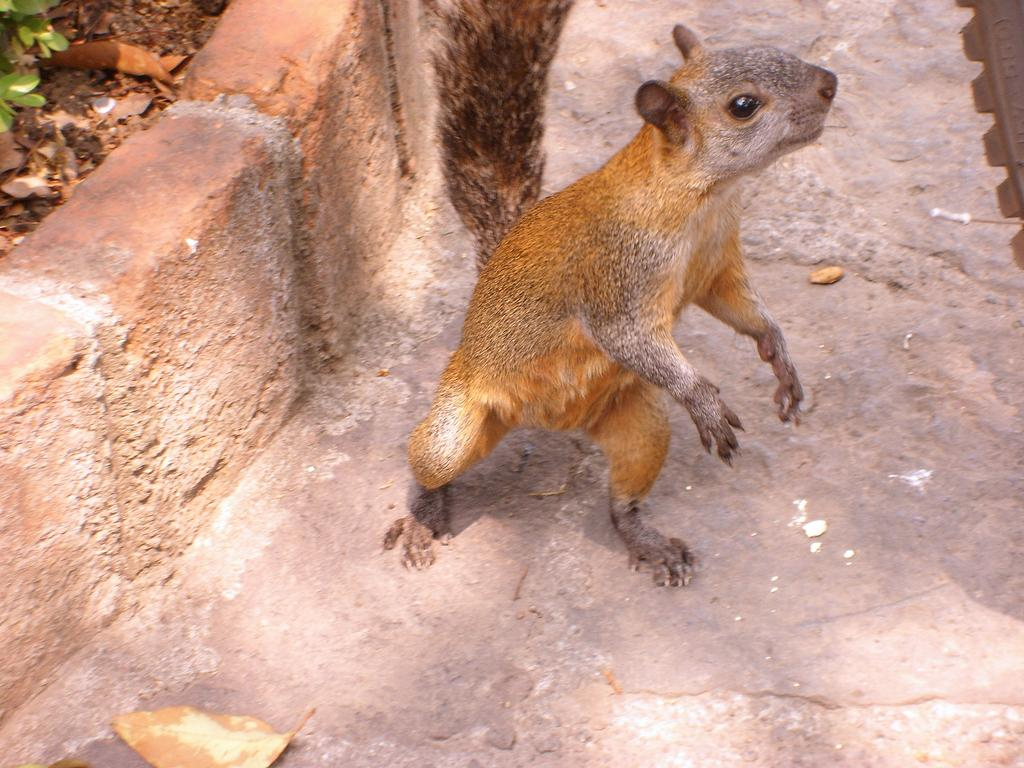What animal can be seen in the image? There is a squirrel in the image. What is the squirrel resting on or standing on? The squirrel is on a surface. What type of material is visible near the squirrel? There are bricks placed in a line beside the squirrel. What type of vegetation is near the squirrel? There are green leafs visible near the squirrel. What type of flesh can be seen in the image? There is no flesh visible in the image; it features a squirrel and bricks. Can you see any fish in the image? There are no fish present in the image. 